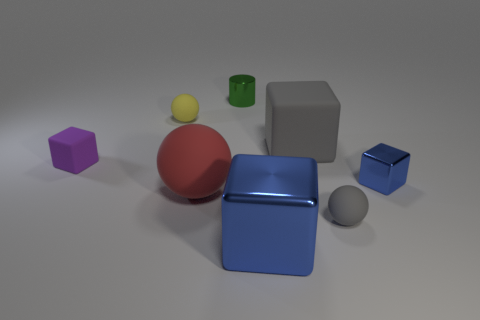Subtract all blue blocks. How many were subtracted if there are1blue blocks left? 1 Subtract 1 cubes. How many cubes are left? 3 Add 2 large matte things. How many objects exist? 10 Subtract all purple cubes. Subtract all blue cylinders. How many cubes are left? 3 Subtract all spheres. How many objects are left? 5 Subtract all balls. Subtract all cyan cylinders. How many objects are left? 5 Add 7 tiny matte things. How many tiny matte things are left? 10 Add 2 small green shiny cubes. How many small green shiny cubes exist? 2 Subtract 1 red spheres. How many objects are left? 7 